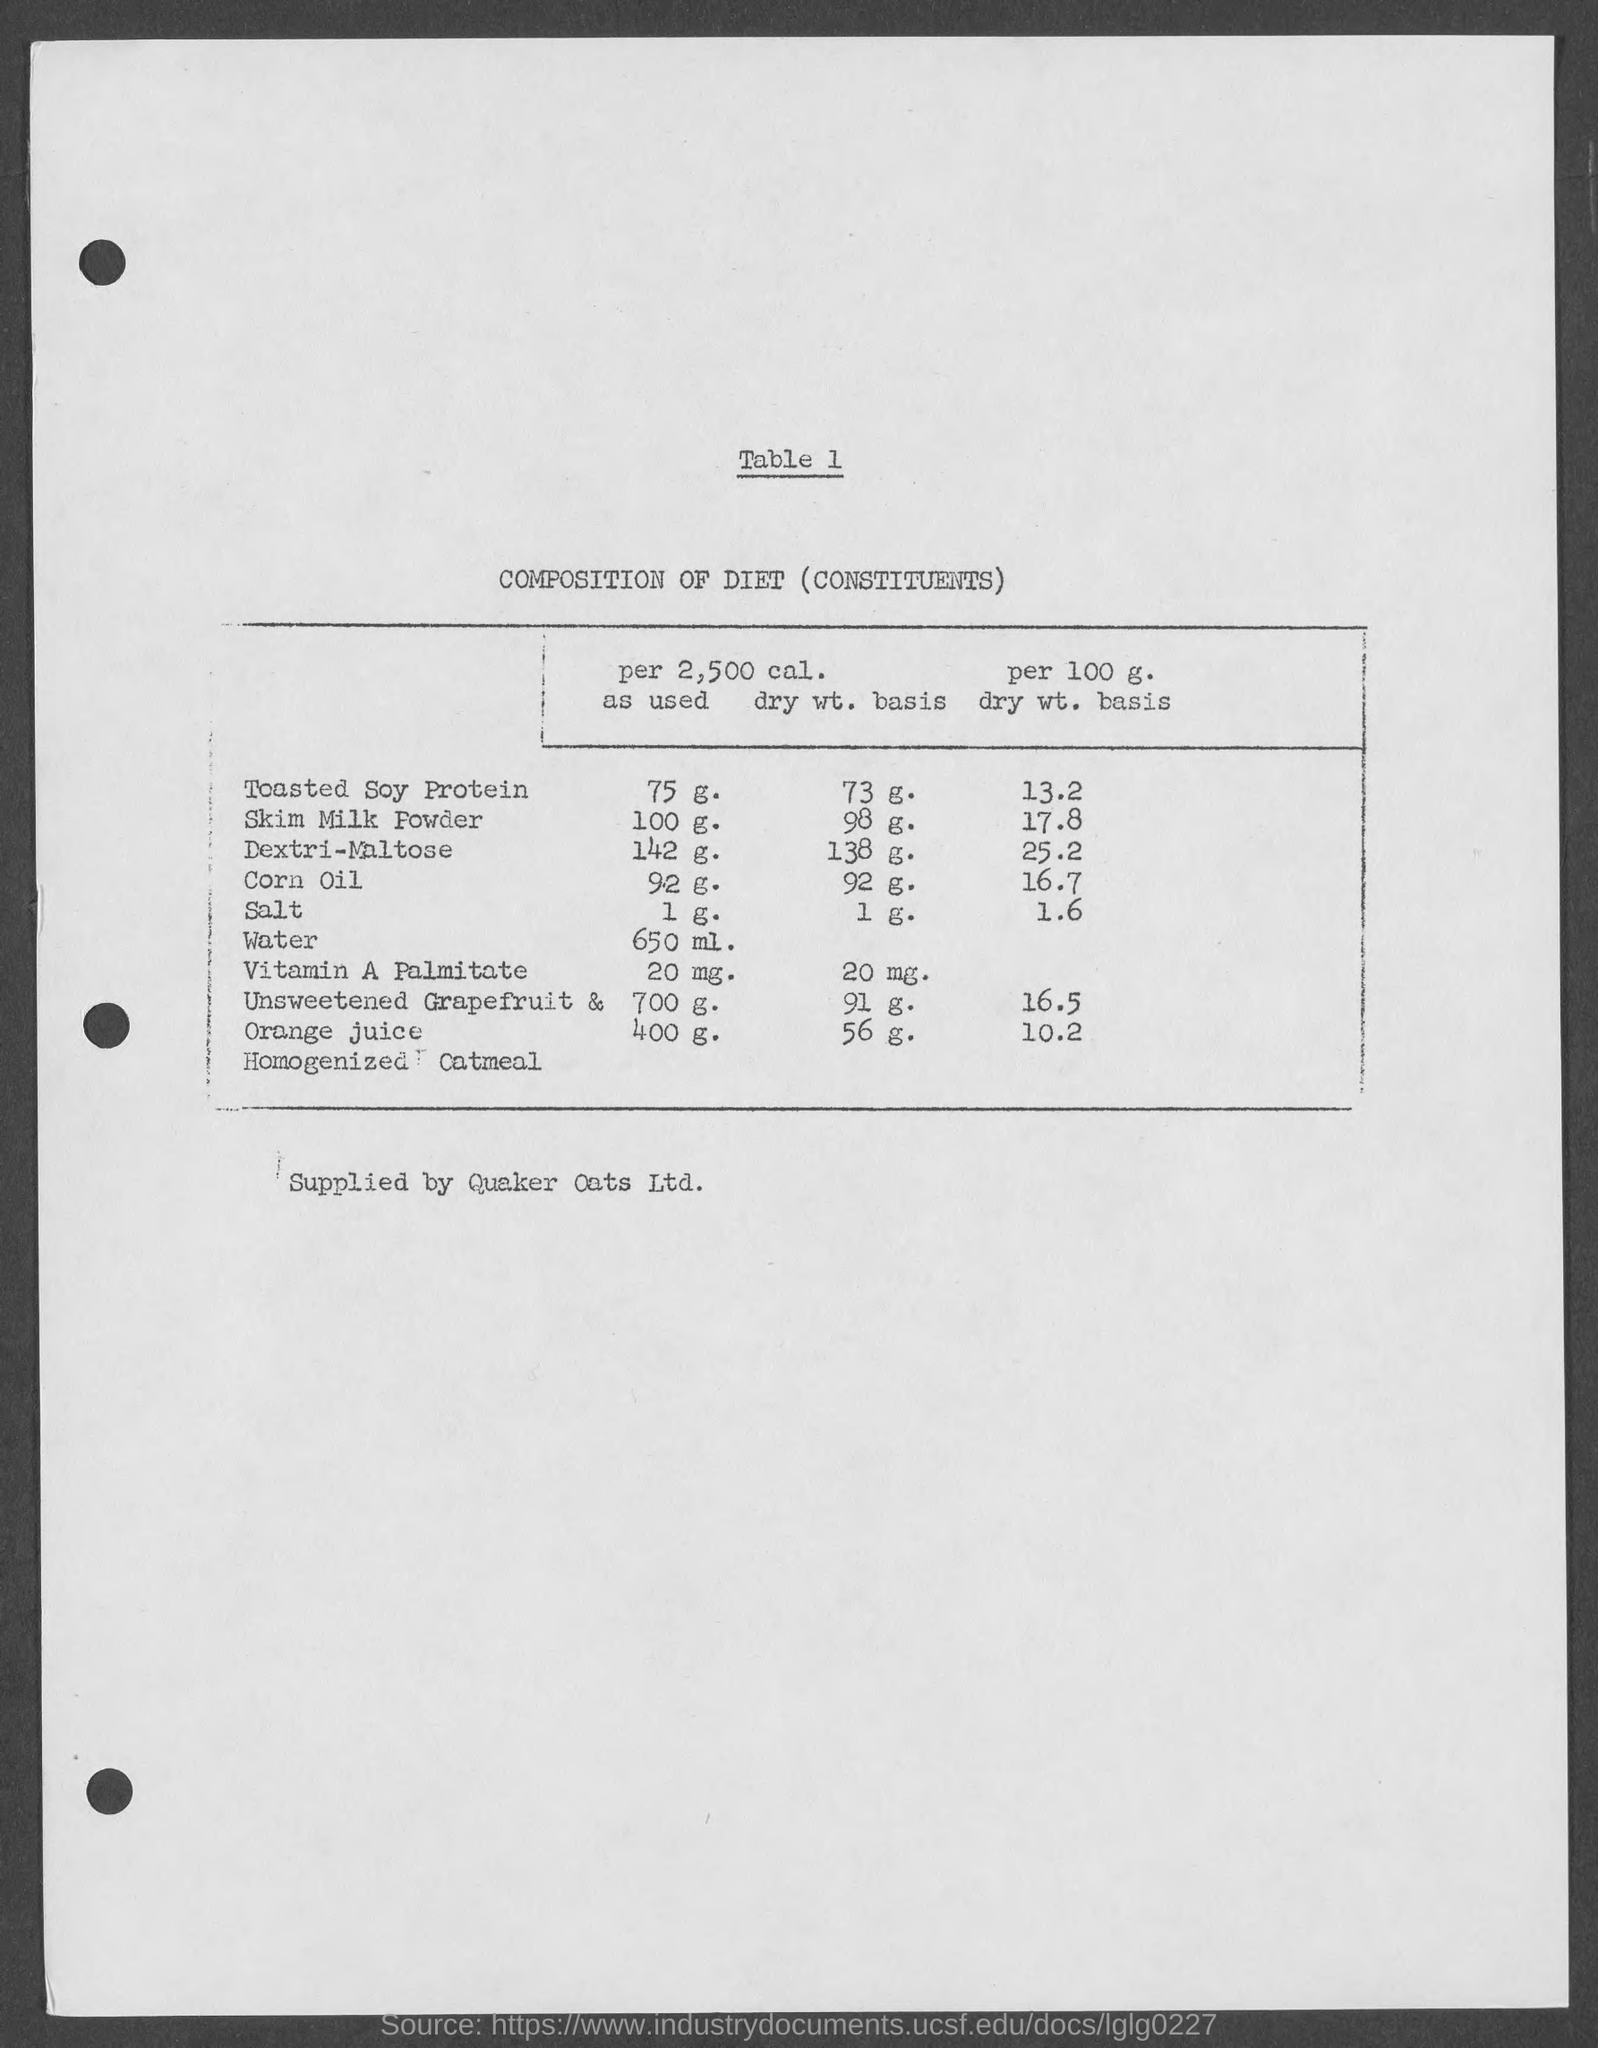Outline some significant characteristics in this image. The table number is 1 and it ranges from 1 to... The table heading is "Composition of Diet (Constituents).". 